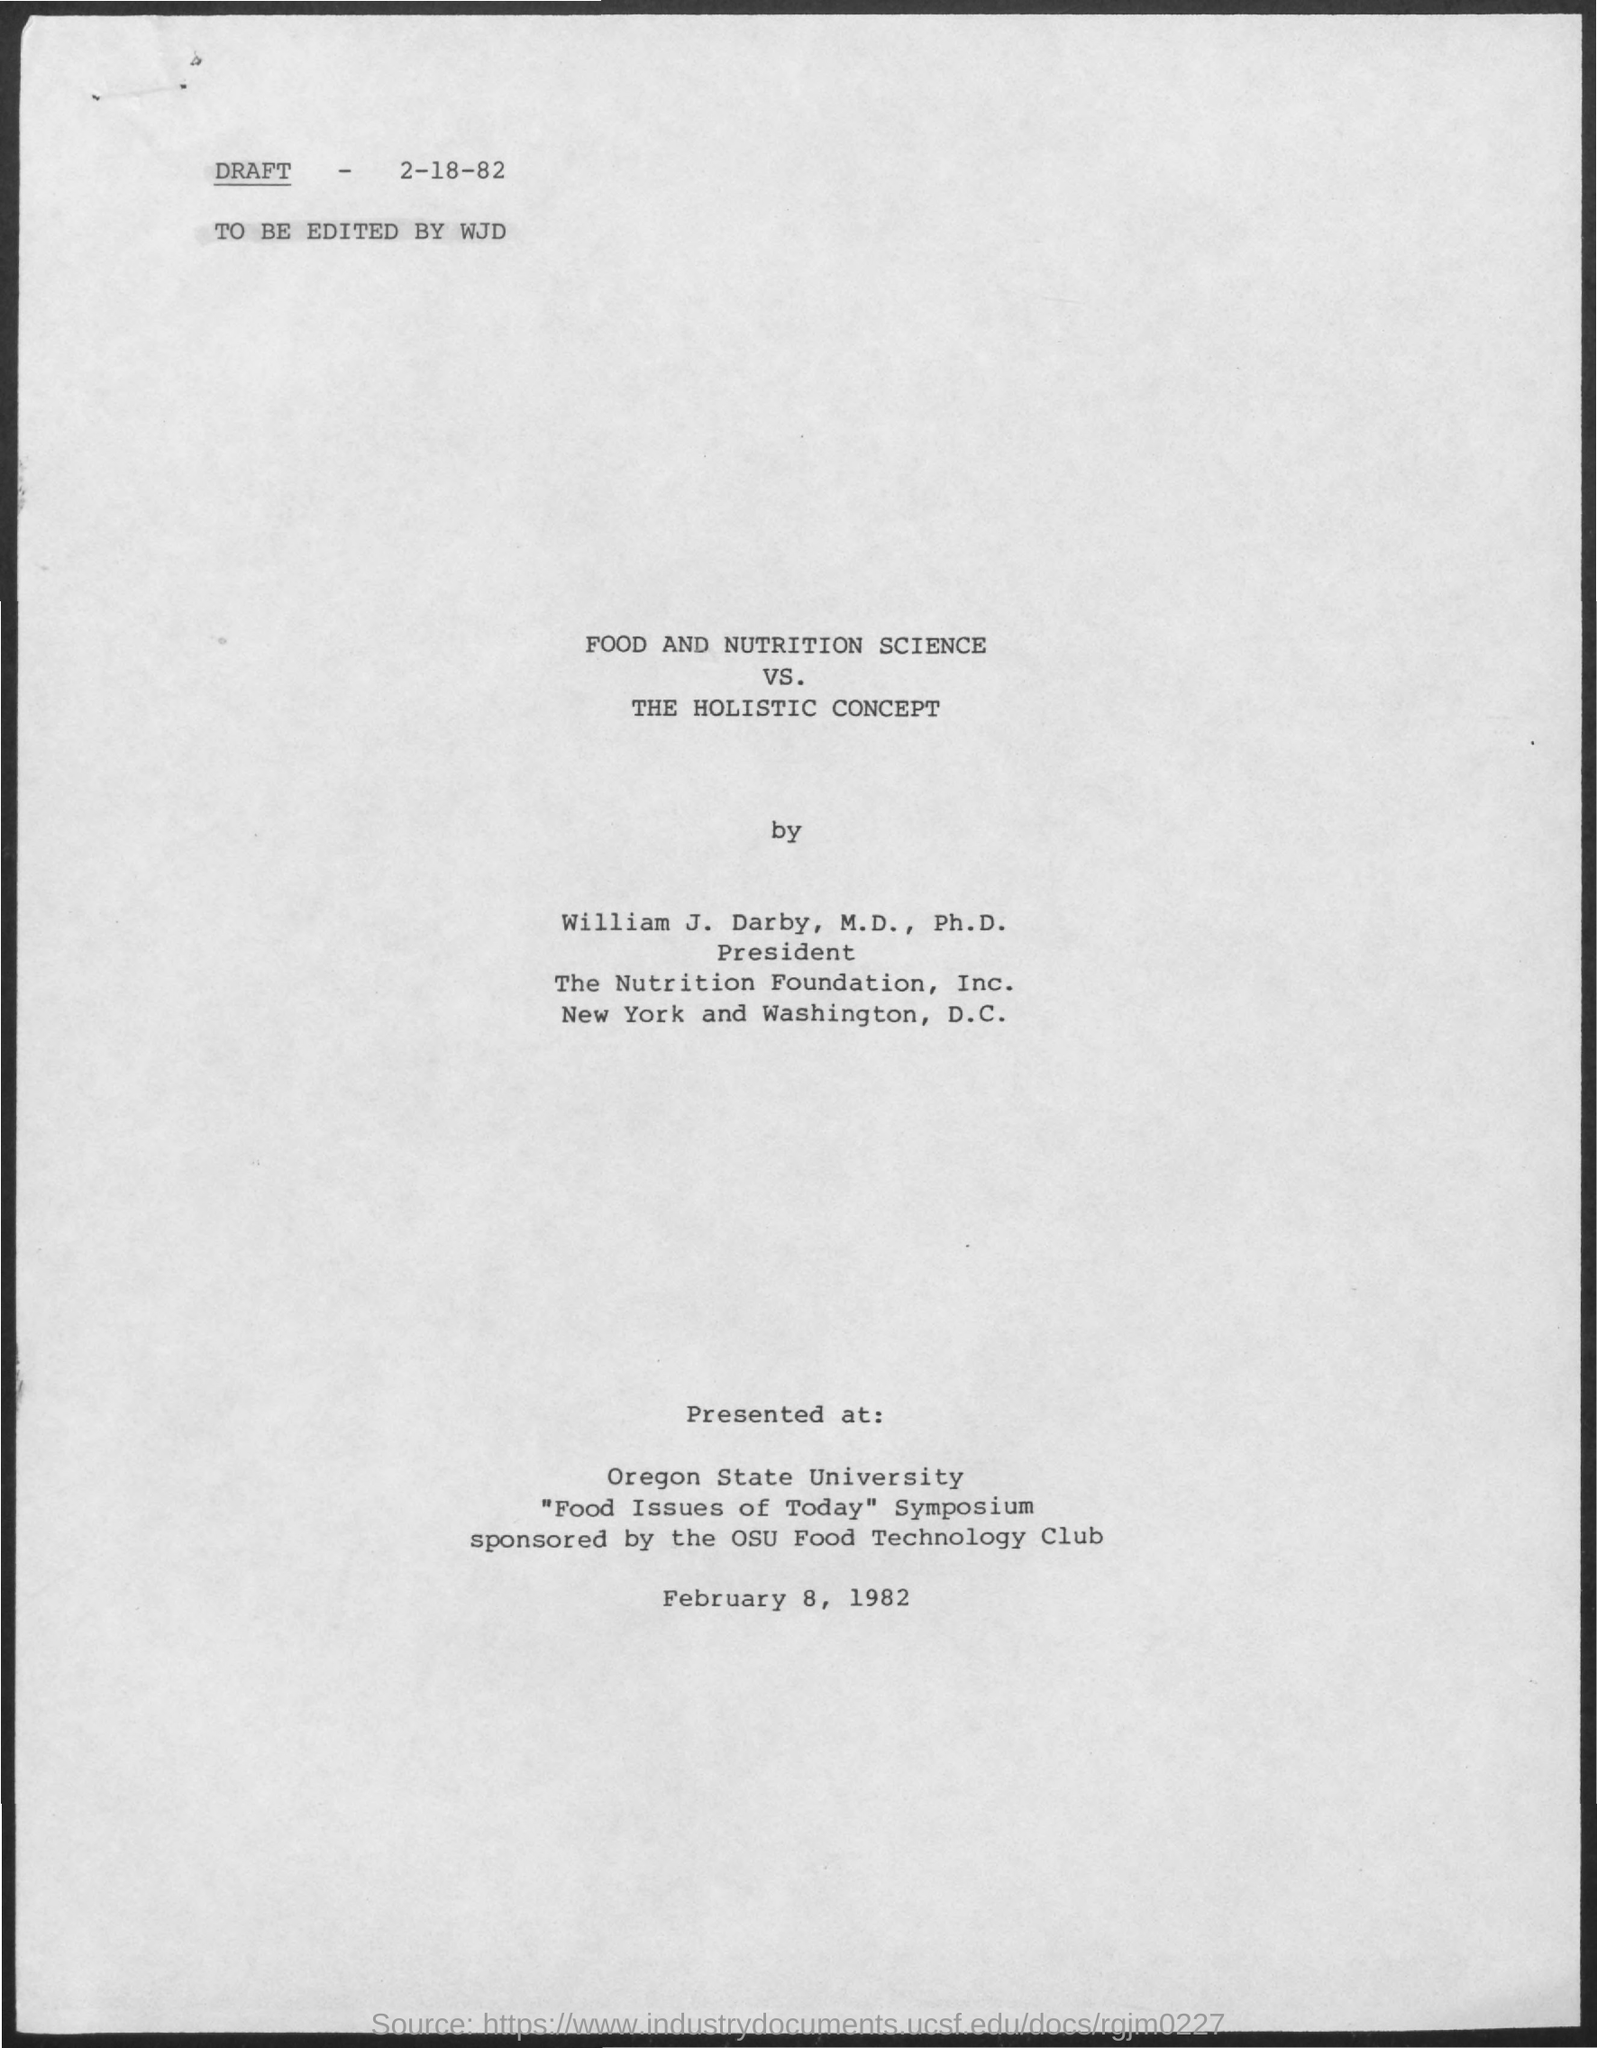by whom the draft was edited ? The draft was edited by an individual with the initials WJD, as indicated by the text 'TO BE EDITED BY WJD' in the top left corner of the document image. 